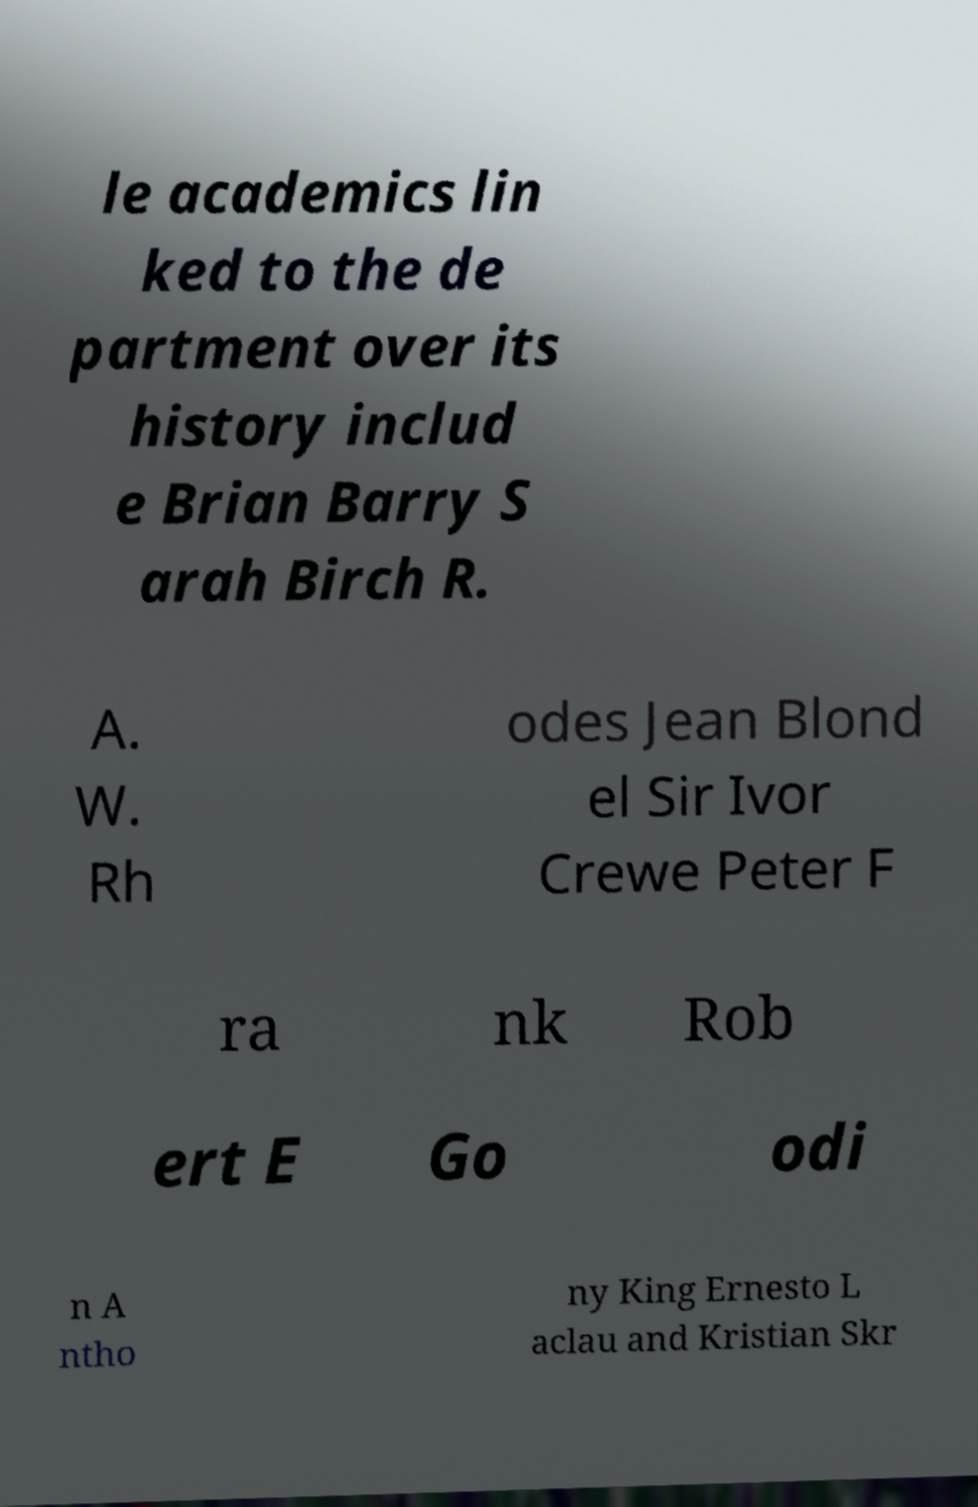I need the written content from this picture converted into text. Can you do that? le academics lin ked to the de partment over its history includ e Brian Barry S arah Birch R. A. W. Rh odes Jean Blond el Sir Ivor Crewe Peter F ra nk Rob ert E Go odi n A ntho ny King Ernesto L aclau and Kristian Skr 